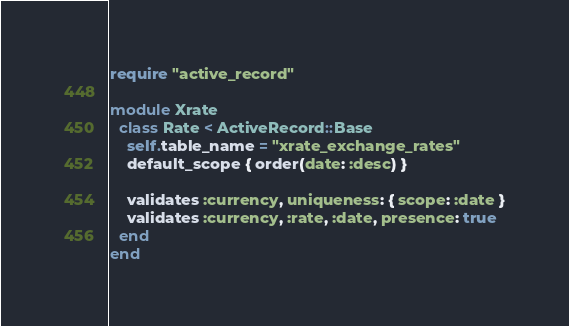Convert code to text. <code><loc_0><loc_0><loc_500><loc_500><_Ruby_>require "active_record"

module Xrate
  class Rate < ActiveRecord::Base
    self.table_name = "xrate_exchange_rates"
    default_scope { order(date: :desc) }

    validates :currency, uniqueness: { scope: :date }
    validates :currency, :rate, :date, presence: true
  end
end
</code> 